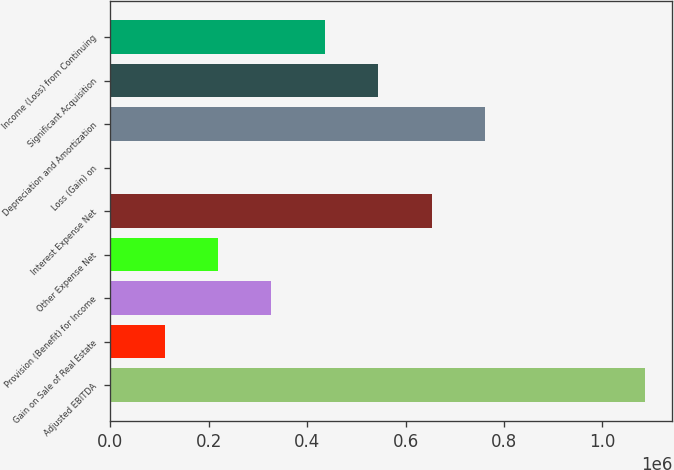<chart> <loc_0><loc_0><loc_500><loc_500><bar_chart><fcel>Adjusted EBITDA<fcel>Gain on Sale of Real Estate<fcel>Provision (Benefit) for Income<fcel>Other Expense Net<fcel>Interest Expense Net<fcel>Loss (Gain) on<fcel>Depreciation and Amortization<fcel>Significant Acquisition<fcel>Income (Loss) from Continuing<nl><fcel>1.08729e+06<fcel>110000<fcel>327175<fcel>218587<fcel>652938<fcel>1412<fcel>761525<fcel>544350<fcel>435762<nl></chart> 